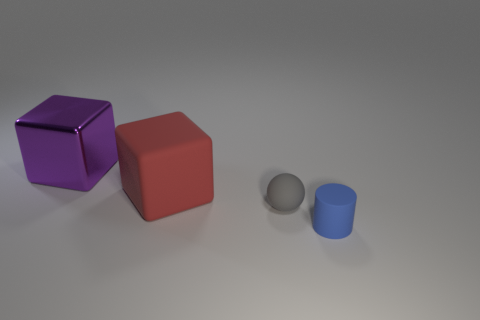If you had to guess, what do you think these objects could be used for in a creative project? These objects could serve various purposes in a creative project. For example, the large cubes could be used as weighted objects in a physics demonstration about balance and mass, while the smaller cubes and cylinder could represent components in a sorting activity based on size or color. Additionally, they could be employed as abstract visual elements in a graphic design or art project, exploring geometric forms and contrasting textures. 